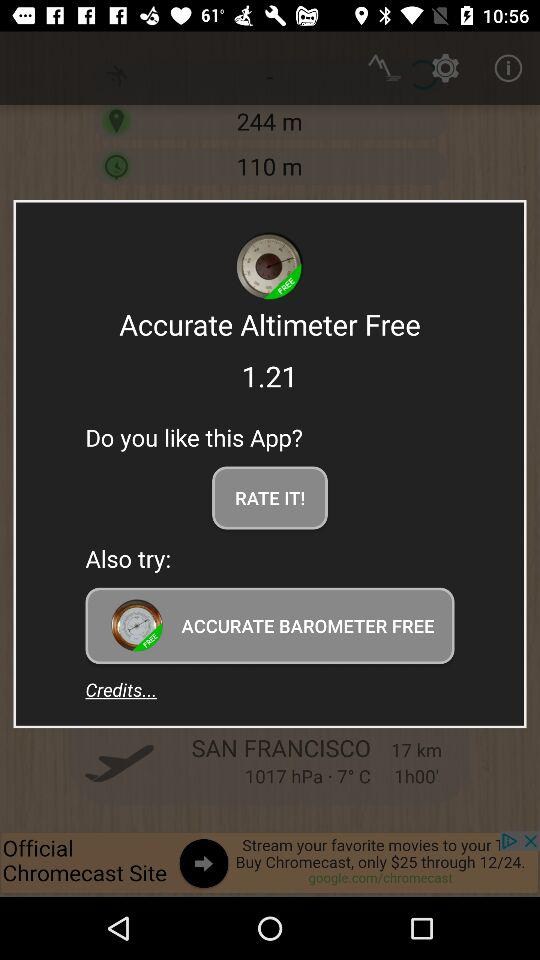What is the version? The version is 1.21. 